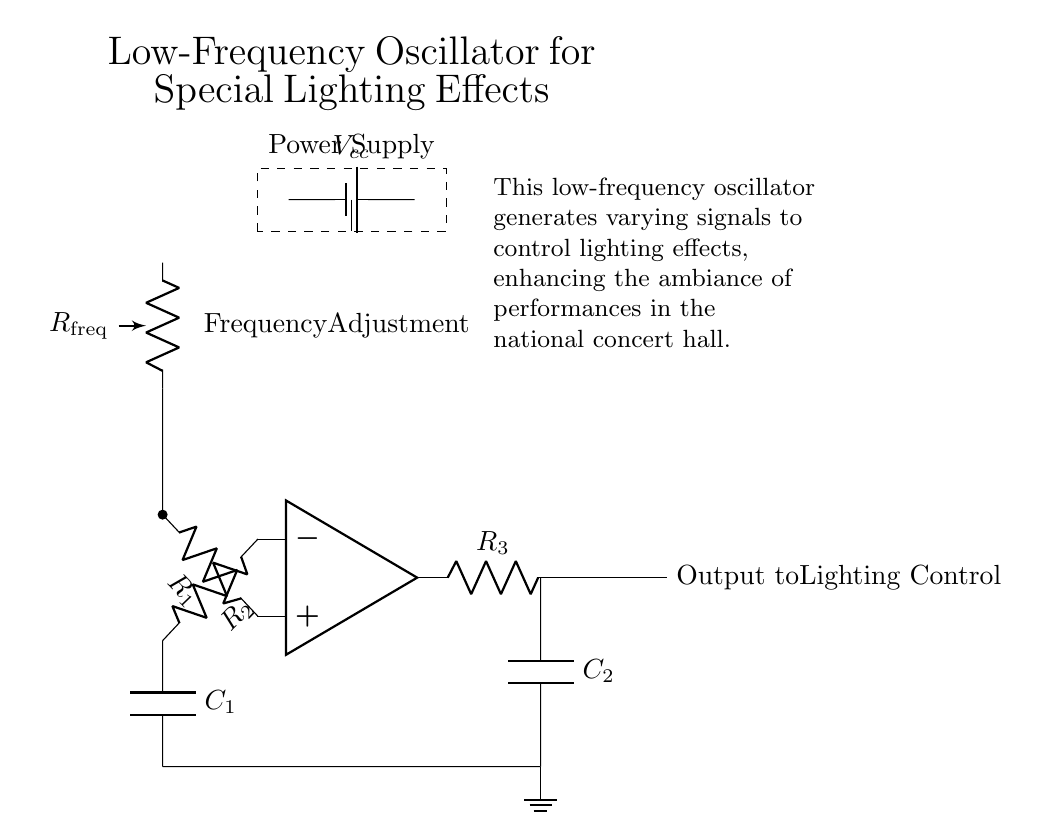What is the type of this circuit? This circuit is an oscillator, specifically designed for generating low-frequency signals to control lighting effects. The presence of operational amplifiers, resistors, and capacitors indicates that it performs oscillation functions.
Answer: Oscillator What is the role of the operational amplifier? The operational amplifier amplifies the input signals and helps to create the oscillating output. It works together with the resistors and capacitors in feedback configuration for stable oscillation.
Answer: Amplification What component adjusts the frequency? The potentiometer labeled R frequency is used to vary the resistance, which directly affects the frequency of the oscillation by changing the time constants in the RC circuit.
Answer: Potentiometer How many resistors are in this circuit? There are three resistors present in the circuit: R1, R2, and R3, each serving different roles in the feedback and timing functions of the oscillator.
Answer: Three What is the output of this oscillator? The output is connected to the lighting control system, delivering varying signals that are instrumental in altering lighting effects during performances.
Answer: Output to lighting control What is the purpose of the capacitors in this circuit? The two capacitors (C1 and C2) are essential in determining the timing and frequency of the oscillation by storing and discharging electrical energy, which influences the oscillation period.
Answer: Timing and frequency What is the power supply voltage? The voltage supplied to this circuit is denoted as Vcc, which powers the operational amplifier and other components. The specific value isn’t shown in the diagram, but it typically indicates a standard operational level for circuits.
Answer: Vcc 